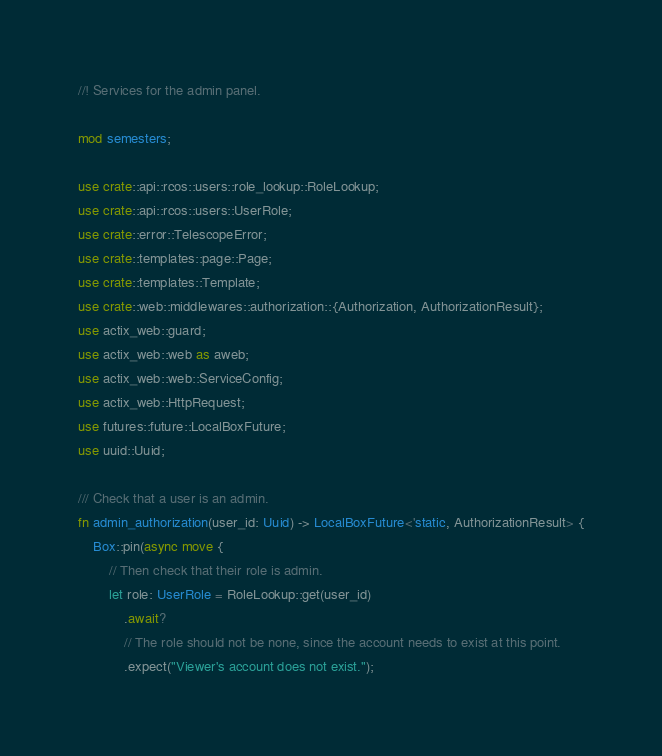Convert code to text. <code><loc_0><loc_0><loc_500><loc_500><_Rust_>//! Services for the admin panel.

mod semesters;

use crate::api::rcos::users::role_lookup::RoleLookup;
use crate::api::rcos::users::UserRole;
use crate::error::TelescopeError;
use crate::templates::page::Page;
use crate::templates::Template;
use crate::web::middlewares::authorization::{Authorization, AuthorizationResult};
use actix_web::guard;
use actix_web::web as aweb;
use actix_web::web::ServiceConfig;
use actix_web::HttpRequest;
use futures::future::LocalBoxFuture;
use uuid::Uuid;

/// Check that a user is an admin.
fn admin_authorization(user_id: Uuid) -> LocalBoxFuture<'static, AuthorizationResult> {
    Box::pin(async move {
        // Then check that their role is admin.
        let role: UserRole = RoleLookup::get(user_id)
            .await?
            // The role should not be none, since the account needs to exist at this point.
            .expect("Viewer's account does not exist.");
</code> 